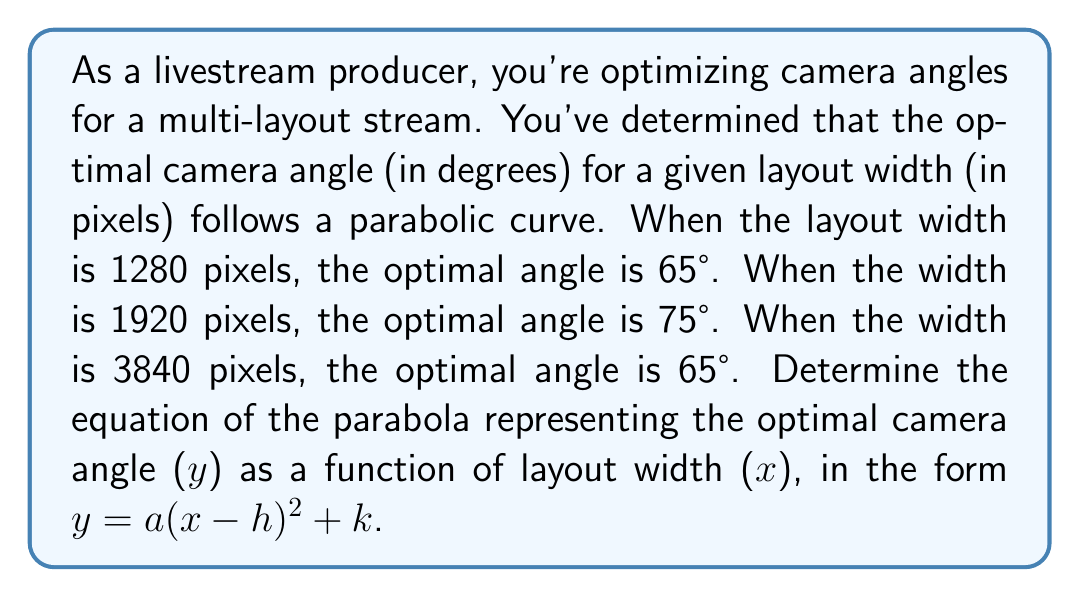Teach me how to tackle this problem. Let's approach this step-by-step:

1) We know the parabola passes through three points: (1280, 65), (1920, 75), and (3840, 65).

2) The general form of a parabola is $y = a(x-h)^2 + k$, where (h,k) is the vertex of the parabola.

3) Since the angle is the same (65°) at both 1280 and 3840 pixels, the axis of symmetry must be halfway between these x-values:

   $h = \frac{1280 + 3840}{2} = 2560$

4) We can use the point (1920, 75) to find k:

   $75 = a(1920-2560)^2 + k$
   $75 = a(-640)^2 + k$
   $75 = 409600a + k$ ... (Equation 1)

5) We can use the point (1280, 65) to create another equation:

   $65 = a(1280-2560)^2 + k$
   $65 = a(-1280)^2 + k$
   $65 = 1638400a + k$ ... (Equation 2)

6) Subtracting Equation 1 from Equation 2:

   $-10 = 1228800a$
   $a = -\frac{10}{1228800} = -\frac{1}{122880}$

7) We can substitute this value of a back into Equation 1 to find k:

   $75 = 409600(-\frac{1}{122880}) + k$
   $75 = -\frac{10}{3} + k$
   $k = 75 + \frac{10}{3} = \frac{235}{3}$

Therefore, the equation of the parabola is:

$y = -\frac{1}{122880}(x-2560)^2 + \frac{235}{3}$
Answer: $y = -\frac{1}{122880}(x-2560)^2 + \frac{235}{3}$ 